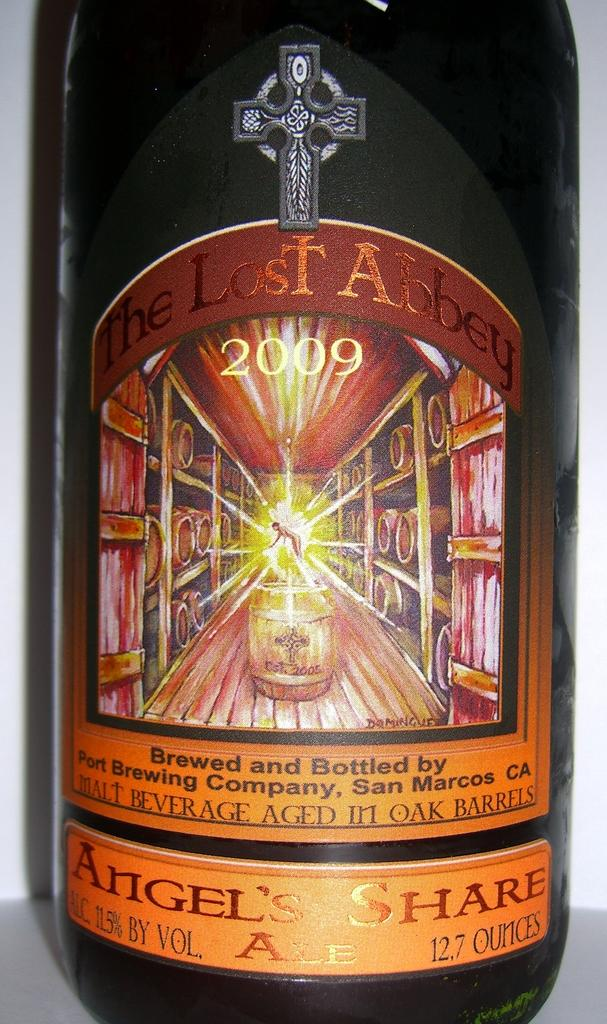<image>
Give a short and clear explanation of the subsequent image. A bottle dated 2009 has an orange label and a cross on it. 